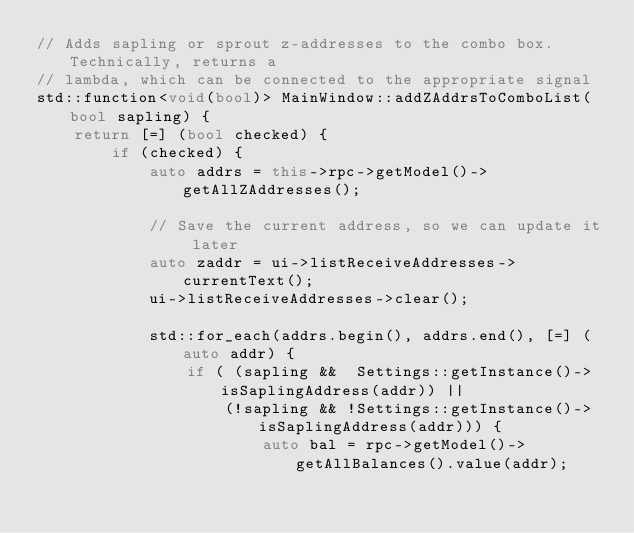Convert code to text. <code><loc_0><loc_0><loc_500><loc_500><_C++_>// Adds sapling or sprout z-addresses to the combo box. Technically, returns a
// lambda, which can be connected to the appropriate signal
std::function<void(bool)> MainWindow::addZAddrsToComboList(bool sapling) {
    return [=] (bool checked) { 
        if (checked) { 
            auto addrs = this->rpc->getModel()->getAllZAddresses();

            // Save the current address, so we can update it later
            auto zaddr = ui->listReceiveAddresses->currentText();
            ui->listReceiveAddresses->clear();

            std::for_each(addrs.begin(), addrs.end(), [=] (auto addr) {
                if ( (sapling &&  Settings::getInstance()->isSaplingAddress(addr)) ||
                    (!sapling && !Settings::getInstance()->isSaplingAddress(addr))) {                        
                        auto bal = rpc->getModel()->getAllBalances().value(addr);</code> 